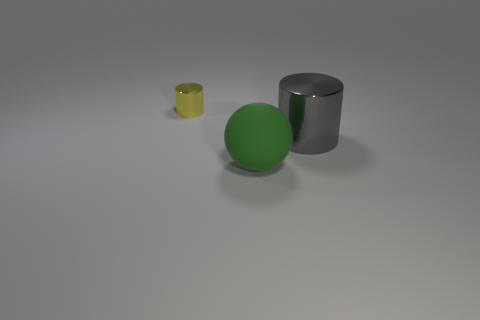How could you use these objects in a simple physics experiment? These objects could be used to demonstrate principles such as gravity, friction, and material density. For example, you could roll the ball and the cylinder on a surface to see which one rolls further, highlighting differences in material resistance and shape. The yellow cup could be used to catch the ball to explore concepts of motion and impact. 